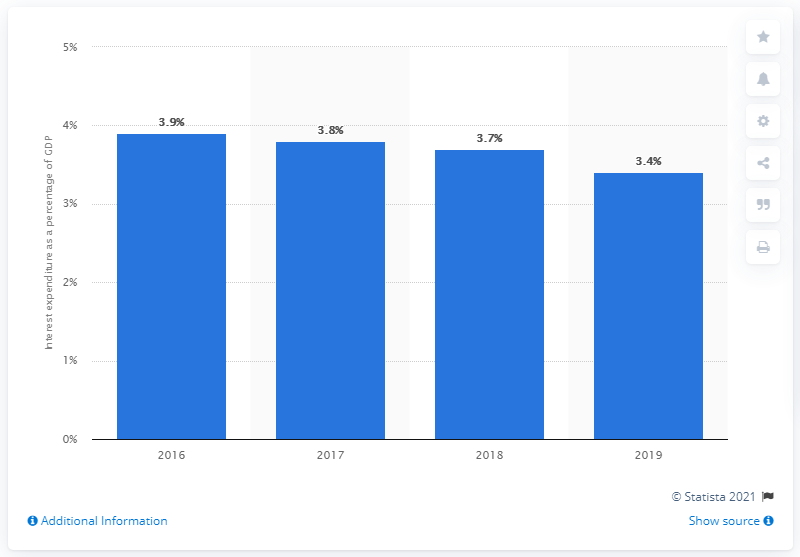Draw attention to some important aspects in this diagram. In 2019, interest expenditure accounted for 3.4% of Italy's GDP. 